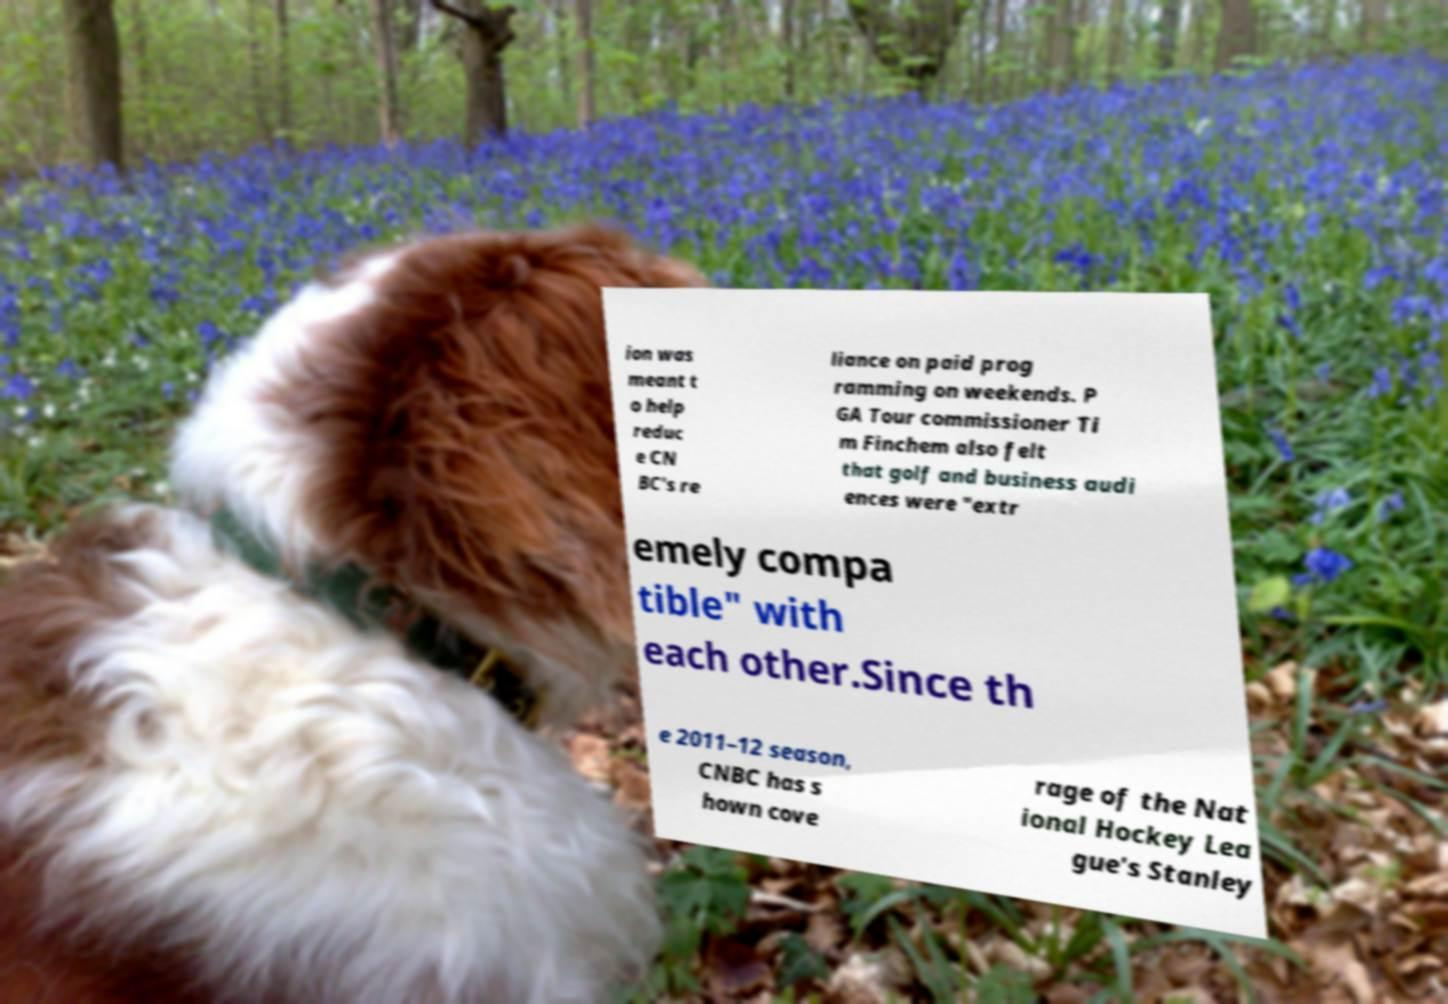What messages or text are displayed in this image? I need them in a readable, typed format. ion was meant t o help reduc e CN BC's re liance on paid prog ramming on weekends. P GA Tour commissioner Ti m Finchem also felt that golf and business audi ences were "extr emely compa tible" with each other.Since th e 2011–12 season, CNBC has s hown cove rage of the Nat ional Hockey Lea gue's Stanley 